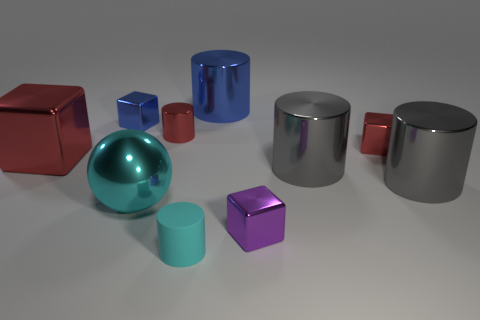Subtract 1 cylinders. How many cylinders are left? 4 Subtract all cyan cylinders. How many cylinders are left? 4 Subtract all tiny red metallic cylinders. How many cylinders are left? 4 Subtract all brown cylinders. Subtract all purple blocks. How many cylinders are left? 5 Subtract all spheres. How many objects are left? 9 Add 7 cyan rubber things. How many cyan rubber things exist? 8 Subtract 0 brown cubes. How many objects are left? 10 Subtract all red cylinders. Subtract all metallic balls. How many objects are left? 8 Add 7 blue cylinders. How many blue cylinders are left? 8 